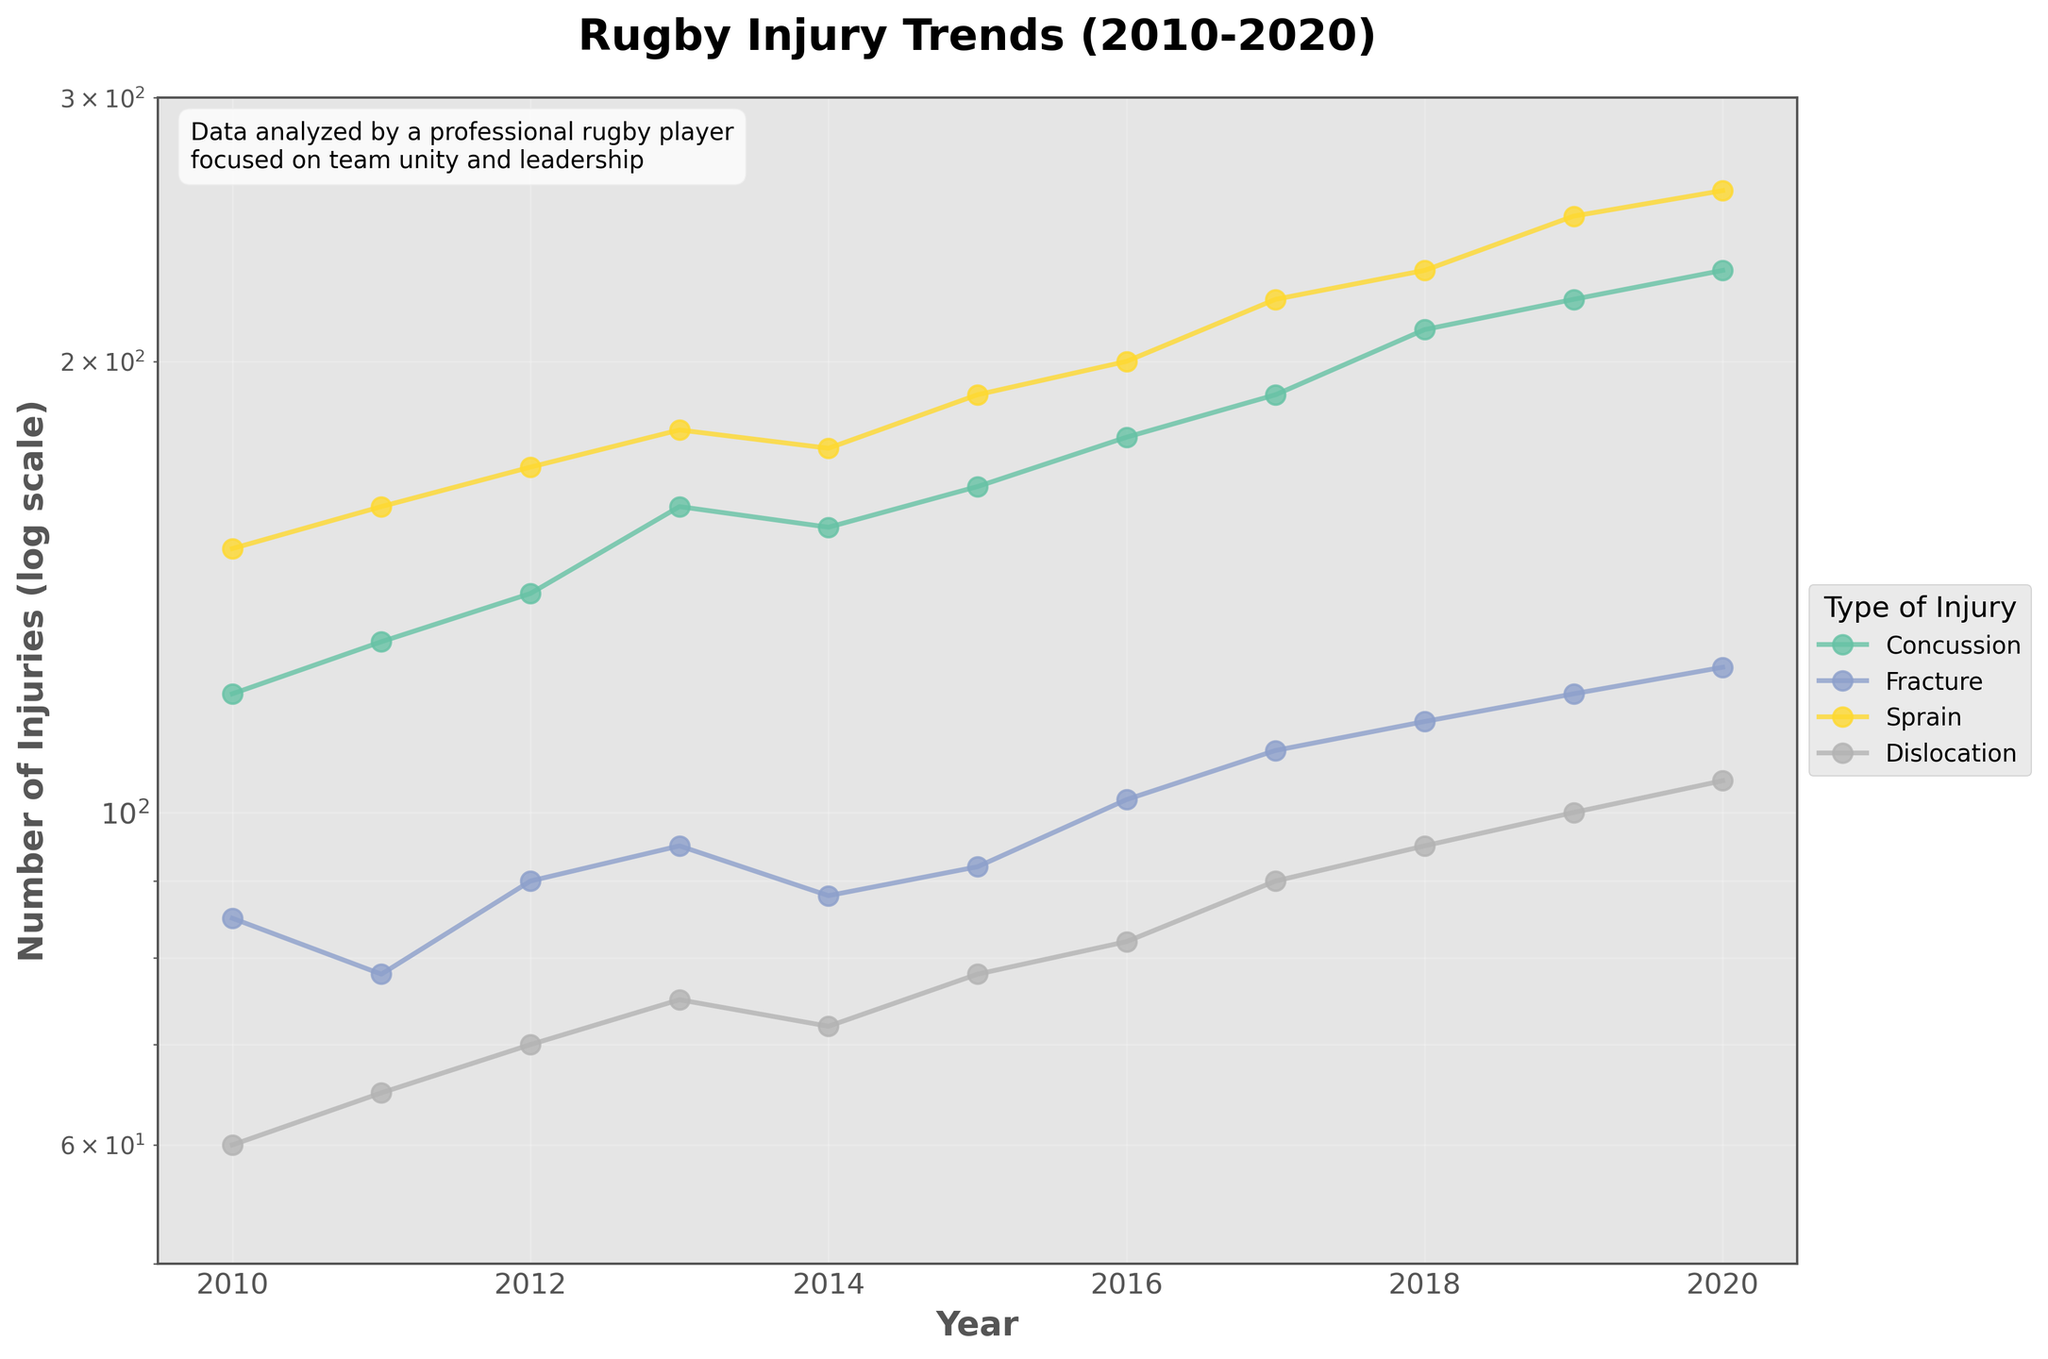What are the four types of injuries shown in the plot? The plot shows four lines, each labeled with a different type of injury. By referring to the legend, we can identify these types.
Answer: Concussion, Fracture, Sprain, Dislocation Between 2010 and 2020, which type of injury consistently had the highest number of injuries each year? Looking at the position of the lines on the log scale, Sprain is the highest line consistently across all years.
Answer: Sprain What is the approximate range of the number of injuries for Concussions over the decade? On the log scale, the number of injuries for Concussions ranges from around 120 in 2010 to about 230 in 2020.
Answer: 120 to 230 In which year did the total number of injuries for all types of injuries reach its peak? By summing up the values for each type of injury per year, the year 2020 has the highest total of (230 + 125 + 260 + 105) = 720.
Answer: 2020 By how much did the number of Dislocations increase from 2010 to 2020? The number of Dislocations in 2010 is 60, and in 2020 it is 105. The difference is 105 - 60.
Answer: 45 Which type of injury showed the most significant increase over the decade? By evaluating the steepness of the log-scaled lines, Sprain shows the most significant increase, going from 150 in 2010 to 260 in 2020.
Answer: Sprain What was the number of Fractures in 2015, and how does it compare to 2010? The number of Fractures in 2015 is 92, and in 2010 it was 85. To compare, 92 - 85 = 7.
Answer: 7 more in 2015 How do the trends of Fractures and Sprains compare over the decade? Both lines show an increasing trend, but Sprains have a steeper increase relative to Fractures when observing the slope of the lines on the log scale.
Answer: Sprains increased more What is the title of the plot and the labels for the axes? The plot's title is "Rugby Injury Trends (2010-2020)". The x-axis label is "Year" and the y-axis label is "Number of Injuries (log scale)".
Answer: "Rugby Injury Trends (2010-2020)", "Year", "Number of Injuries (log scale)" From the figure, what year did each type of injury reach or exceed 100 injuries? By observing when each specific type surpasses the 100 mark: Concussion in 2010, Fracture in 2020, Sprain in 2010, and Dislocation in 2019.
Answer: 2010, 2020, 2010, 2019 